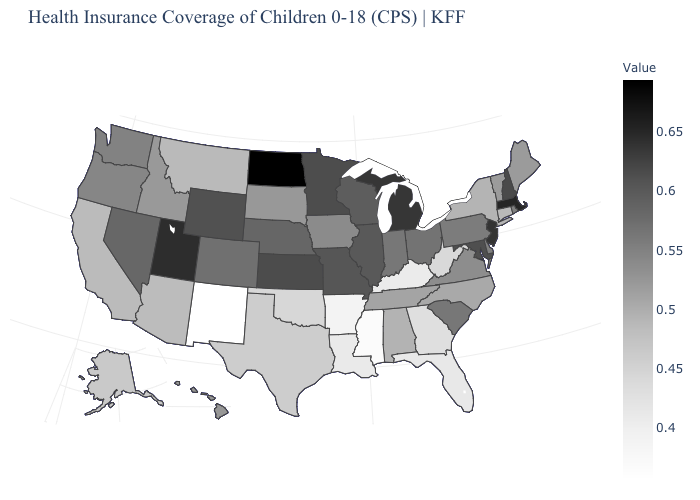Among the states that border Ohio , which have the lowest value?
Be succinct. Kentucky. Among the states that border New Jersey , does New York have the lowest value?
Short answer required. Yes. Which states have the lowest value in the West?
Short answer required. New Mexico. Among the states that border Utah , does Idaho have the highest value?
Concise answer only. No. Does Missouri have a lower value than Virginia?
Write a very short answer. No. Does the map have missing data?
Keep it brief. No. Does Nevada have a higher value than New Jersey?
Give a very brief answer. No. Does South Carolina have the highest value in the USA?
Give a very brief answer. No. Does South Dakota have the lowest value in the MidWest?
Short answer required. Yes. 